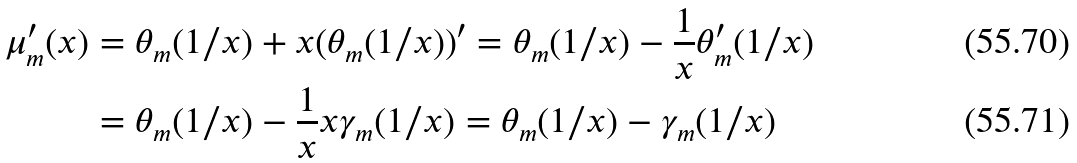<formula> <loc_0><loc_0><loc_500><loc_500>\mu _ { m } ^ { \prime } ( x ) & = \theta _ { m } ( 1 / x ) + x ( \theta _ { m } ( 1 / x ) ) ^ { \prime } = \theta _ { m } ( 1 / x ) - \frac { 1 } { x } \theta _ { m } ^ { \prime } ( 1 / x ) \\ & = \theta _ { m } ( 1 / x ) - \frac { 1 } { x } x \gamma _ { m } ( 1 / x ) = \theta _ { m } ( 1 / x ) - \gamma _ { m } ( 1 / x )</formula> 